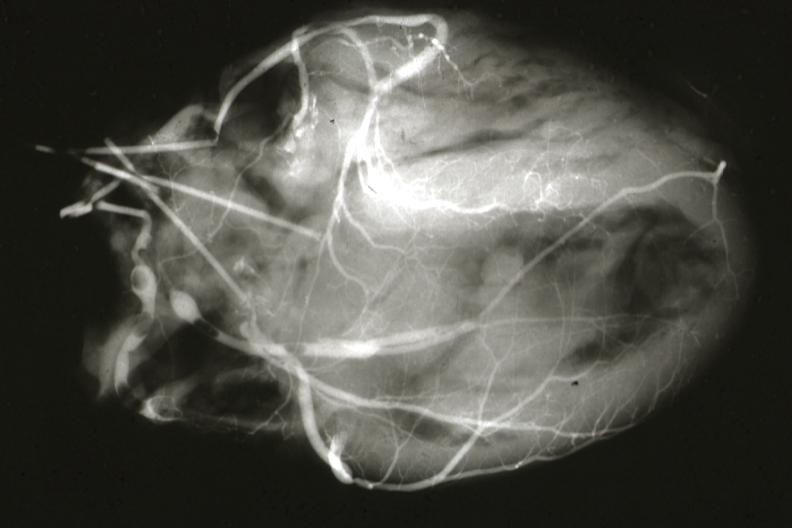what does this image show?
Answer the question using a single word or phrase. Postmortangiogram of coronary arteries 